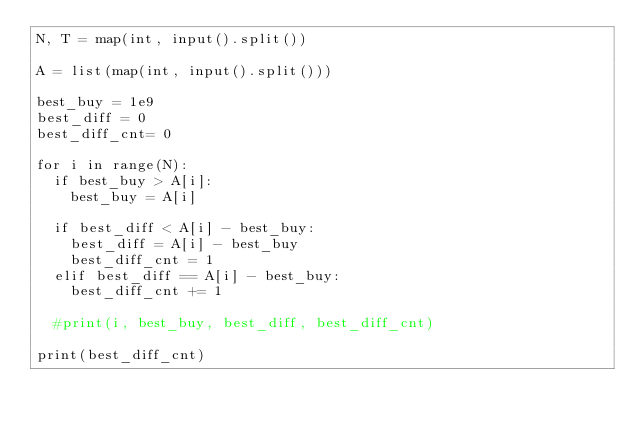Convert code to text. <code><loc_0><loc_0><loc_500><loc_500><_Python_>N, T = map(int, input().split())

A = list(map(int, input().split()))

best_buy = 1e9
best_diff = 0
best_diff_cnt= 0

for i in range(N):
  if best_buy > A[i]:
    best_buy = A[i]
  
  if best_diff < A[i] - best_buy:
    best_diff = A[i] - best_buy
    best_diff_cnt = 1
  elif best_diff == A[i] - best_buy:
    best_diff_cnt += 1
    
  #print(i, best_buy, best_diff, best_diff_cnt)
    
print(best_diff_cnt)</code> 